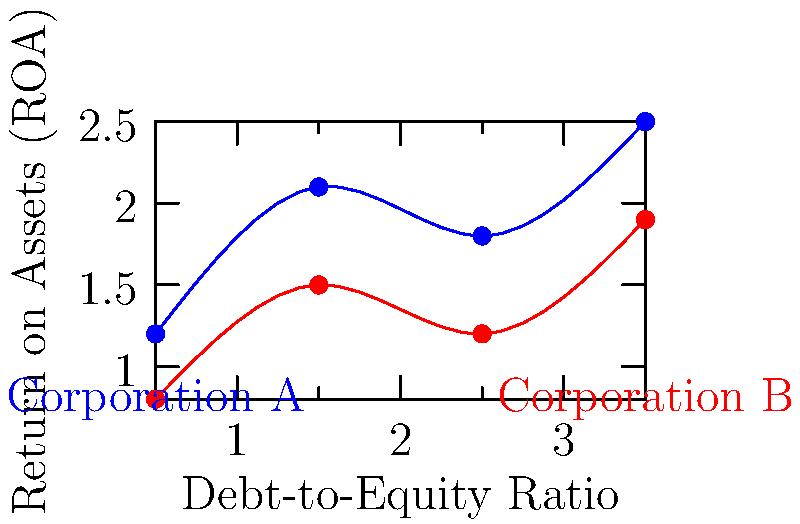Given the graph showing the relationship between Debt-to-Equity Ratio and Return on Assets (ROA) for two corporations, which corporation demonstrates a generally higher ROA across the observed Debt-to-Equity ratios? How might this information be relevant in a corporate law context? To answer this question, we need to analyze the graph and understand its implications:

1. The x-axis represents the Debt-to-Equity Ratio, while the y-axis represents the Return on Assets (ROA).

2. Two corporations are represented: Corporation A (blue line) and Corporation B (red line).

3. Comparing the two lines:
   - Corporation A's line (blue) is consistently higher on the y-axis than Corporation B's line (red).
   - This means that for any given Debt-to-Equity Ratio, Corporation A generally has a higher ROA.

4. The higher ROA indicates that Corporation A is more efficient at using its assets to generate profits.

5. In a corporate law context, this information is relevant because:
   - It can affect investment decisions and shareholder interests.
   - It may influence merger and acquisition considerations.
   - It could be important in cases involving corporate governance or fiduciary duty.
   - Higher profitability might impact legal strategies in contract negotiations or disputes.

6. A corporate lawyer might use this information to:
   - Advise clients on potential investments or partnerships.
   - Develop arguments in shareholder disputes or corporate litigation.
   - Assess the financial health of a company in various legal contexts.

Therefore, Corporation A demonstrates a generally higher ROA across the observed Debt-to-Equity ratios, which has several implications in corporate law practice.
Answer: Corporation A; higher ROA indicates better asset utilization, relevant for investment decisions, mergers, corporate governance, and legal strategies in corporate law. 